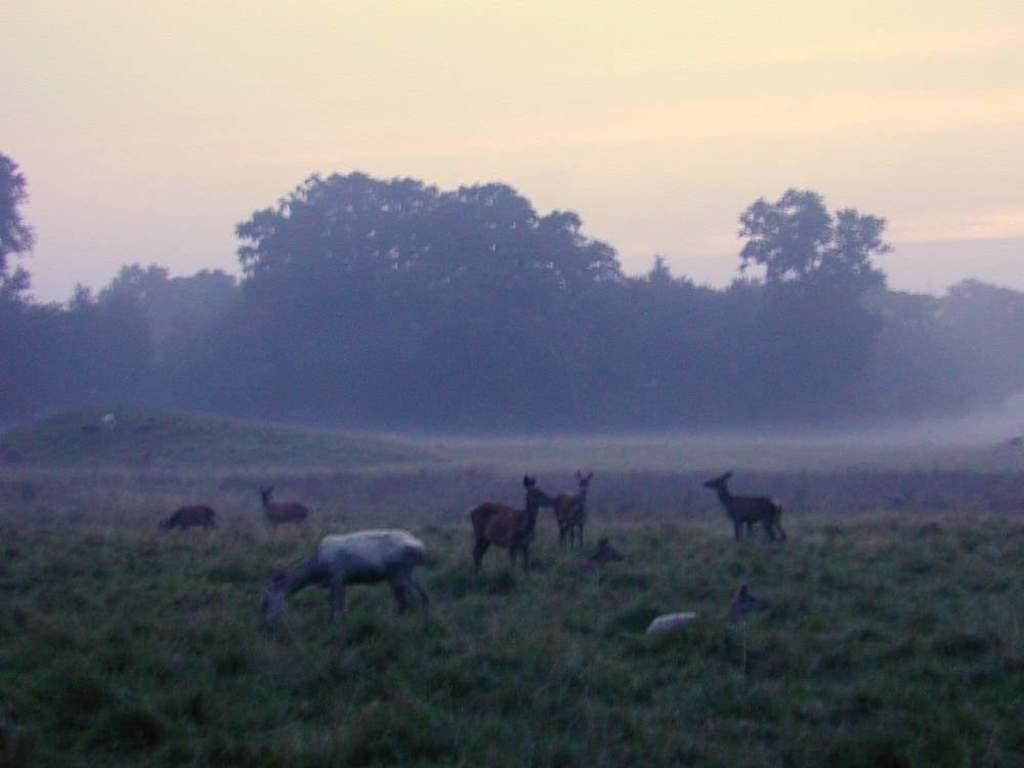What type of living organisms can be seen in the image? There are animals in the image. What is the position of the animals in the image? The animals are standing on the ground. What color are the animals in the image? The animals are in brown color. What can be seen in the background of the image? There are many trees in the background of the image. What is the color of the sky in the image? The sky is white in the image. What type of lace is used to decorate the doll in the image? There is no doll present in the image, and therefore no lace can be observed. What type of debt is being discussed by the animals in the image? There is no mention of debt in the image, and the animals are not engaged in any conversation. 